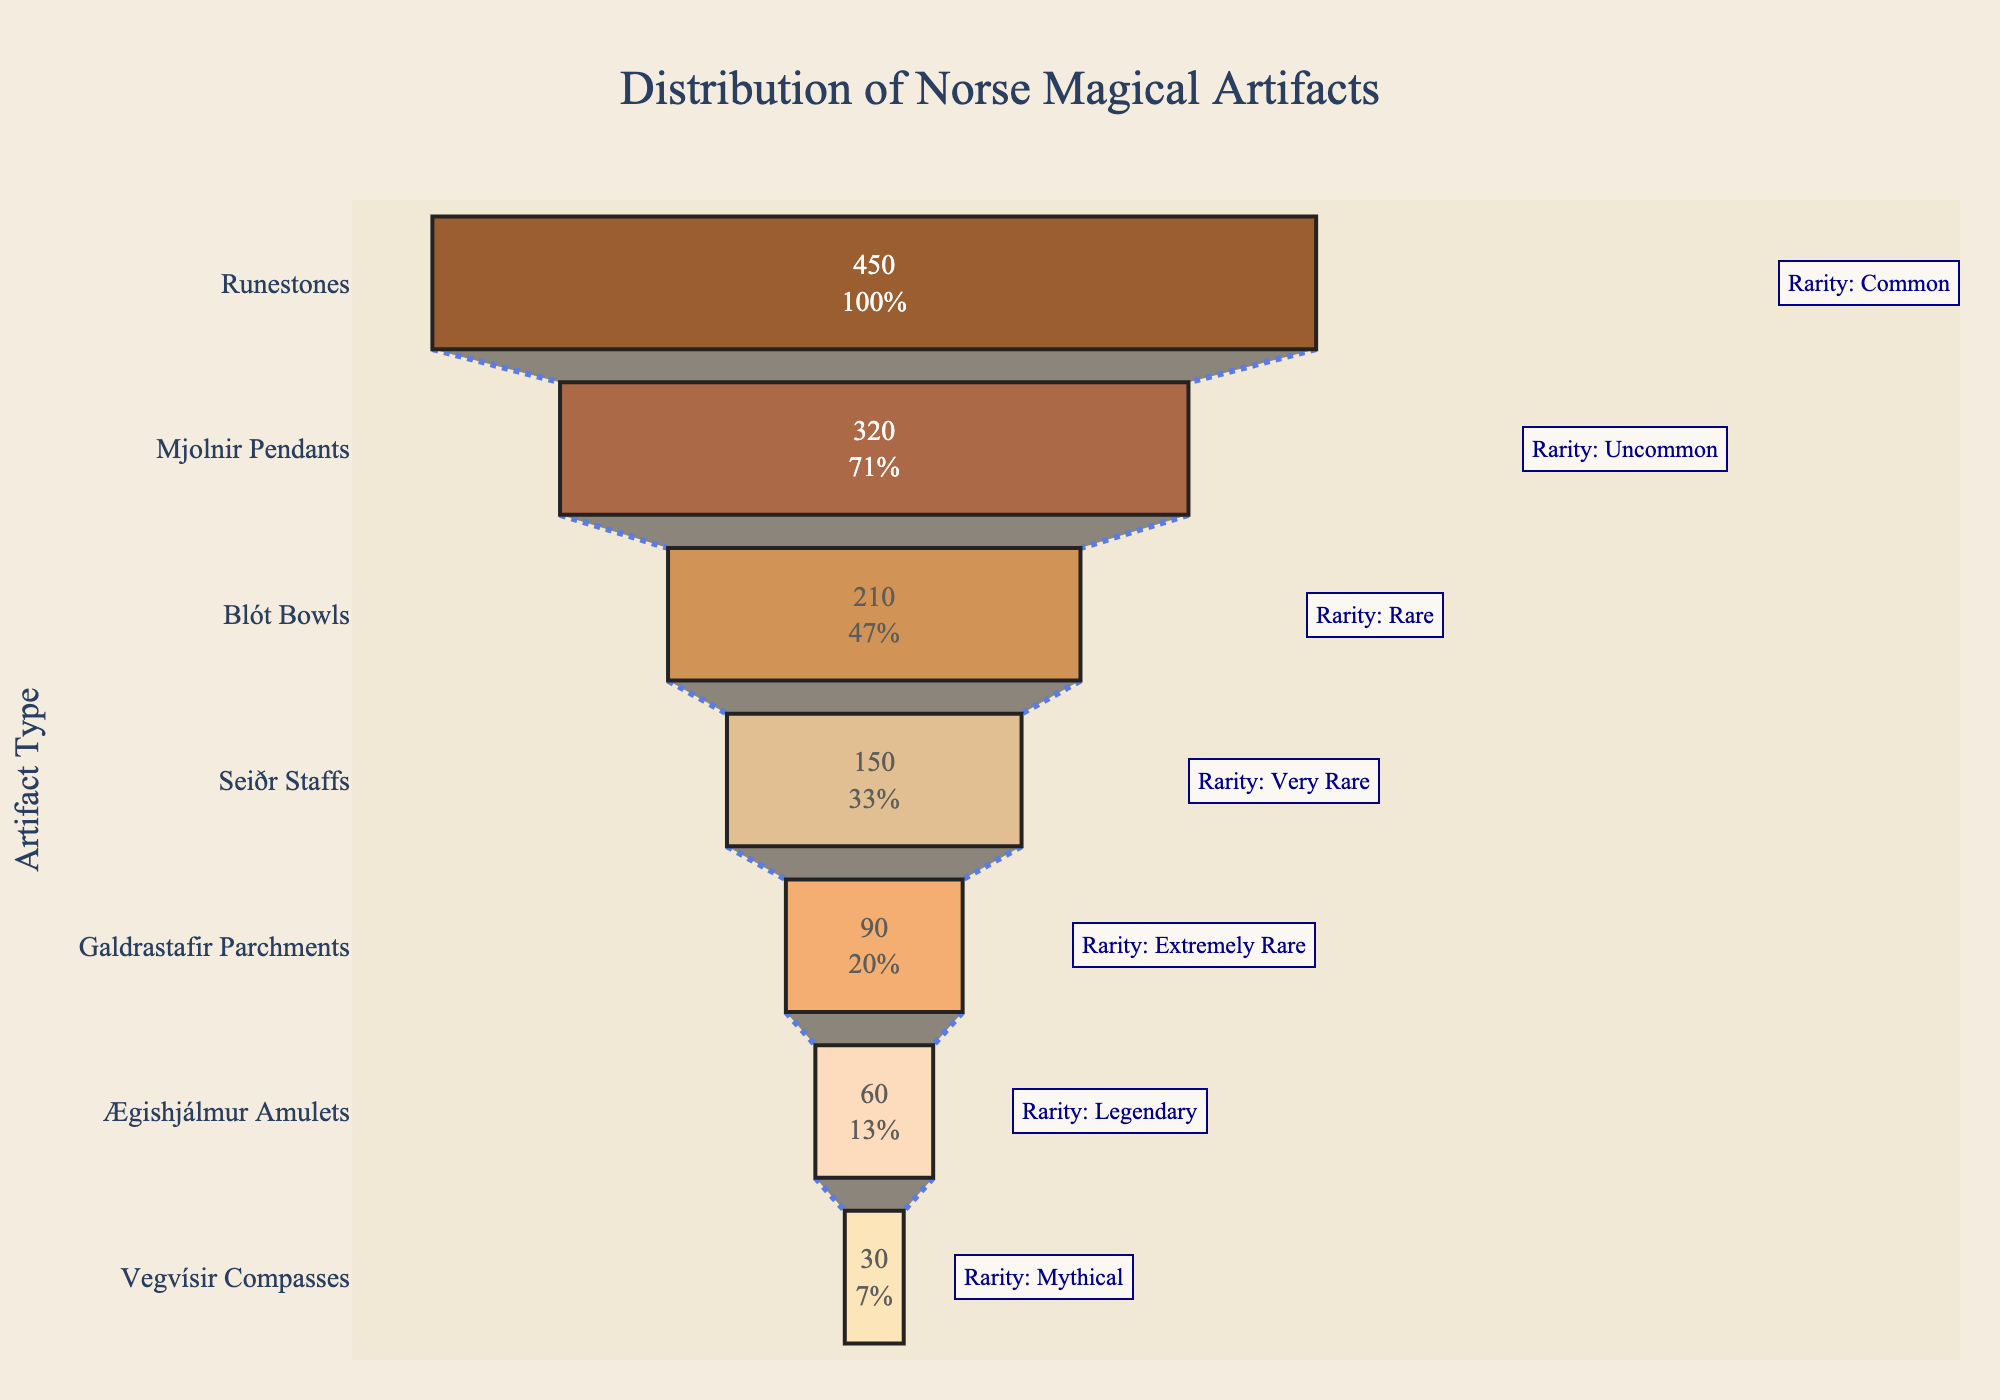How many artifact types are displayed in the funnel chart? Count the different artifact types listed on the y-axis. There are seven different types.
Answer: 7 What is the title of the funnel chart? The title is typically found at the top of the chart and is a textual element indicating the subject. The title of the funnel chart is "Distribution of Norse Magical Artifacts".
Answer: Distribution of Norse Magical Artifacts Which artifact type has the highest count? Look for the longest bar at the top of the funnel chart. The "Runestones" have the highest count.
Answer: Runestones What is the color of the 'Mjolnir Pendants' bar in the chart? Identify the specific shade given to 'Mjolnir Pendants' within the funnel. It is light brown.
Answer: light brown Which artifact type is listed as "Very Rare"? Locate the annotation text next to each artifact type for the rarity information. 'Seiðr Staffs' are labeled as "Very Rare".
Answer: Seiðr Staffs What is the difference in count between the most common and the rarest artifact type? Subtract the count of 'Vegvísir Compasses' (30) from the count of 'Runestones' (450). 450 - 30 = 420.
Answer: 420 How does the count of 'Blót Bowls' compare to 'Ægishjálmur Amulets'? Compare the lengths of the bars for each artifact type. 'Blót Bowls' have a count of 210, while 'Ægishjálmur Amulets' have a count of 60. Hence, 'Blót Bowls' have a higher count.
Answer: Blót Bowls have a higher count What percentage of the initial value does 'Galdrastafir Parchments' represent? Identify the percentage information inside the 'Galdrastafir Parchments' bar. It represents approximately 13.33% of the initial value.
Answer: ~13.33% What is the total count of the artifacts depicted in the chart? Summing the counts of all artifact types: 450 + 320 + 210 + 150 + 90 + 60 + 30 = 1310.
Answer: 1310 Which artifact type is represented with the "Legendary" rarity? Check the rarity annotation next to each artifact type for this information. 'Ægishjálmur Amulets' are listed as "Legendary".
Answer: Ægishjálmur Amulets 